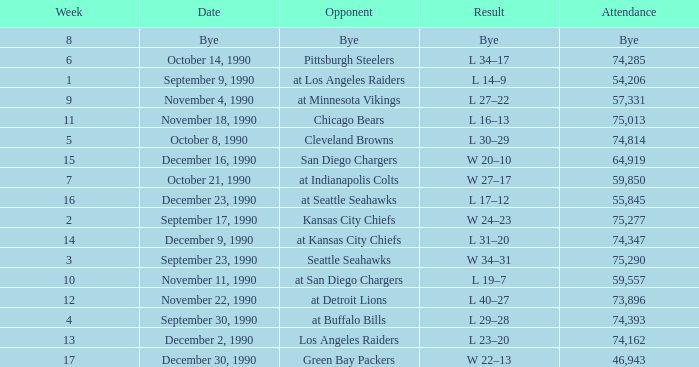Help me parse the entirety of this table. {'header': ['Week', 'Date', 'Opponent', 'Result', 'Attendance'], 'rows': [['8', 'Bye', 'Bye', 'Bye', 'Bye'], ['6', 'October 14, 1990', 'Pittsburgh Steelers', 'L 34–17', '74,285'], ['1', 'September 9, 1990', 'at Los Angeles Raiders', 'L 14–9', '54,206'], ['9', 'November 4, 1990', 'at Minnesota Vikings', 'L 27–22', '57,331'], ['11', 'November 18, 1990', 'Chicago Bears', 'L 16–13', '75,013'], ['5', 'October 8, 1990', 'Cleveland Browns', 'L 30–29', '74,814'], ['15', 'December 16, 1990', 'San Diego Chargers', 'W 20–10', '64,919'], ['7', 'October 21, 1990', 'at Indianapolis Colts', 'W 27–17', '59,850'], ['16', 'December 23, 1990', 'at Seattle Seahawks', 'L 17–12', '55,845'], ['2', 'September 17, 1990', 'Kansas City Chiefs', 'W 24–23', '75,277'], ['14', 'December 9, 1990', 'at Kansas City Chiefs', 'L 31–20', '74,347'], ['3', 'September 23, 1990', 'Seattle Seahawks', 'W 34–31', '75,290'], ['10', 'November 11, 1990', 'at San Diego Chargers', 'L 19–7', '59,557'], ['12', 'November 22, 1990', 'at Detroit Lions', 'L 40–27', '73,896'], ['4', 'September 30, 1990', 'at Buffalo Bills', 'L 29–28', '74,393'], ['13', 'December 2, 1990', 'Los Angeles Raiders', 'L 23–20', '74,162'], ['17', 'December 30, 1990', 'Green Bay Packers', 'W 22–13', '46,943']]} Who is the opponent when the attendance is 57,331? At minnesota vikings. 